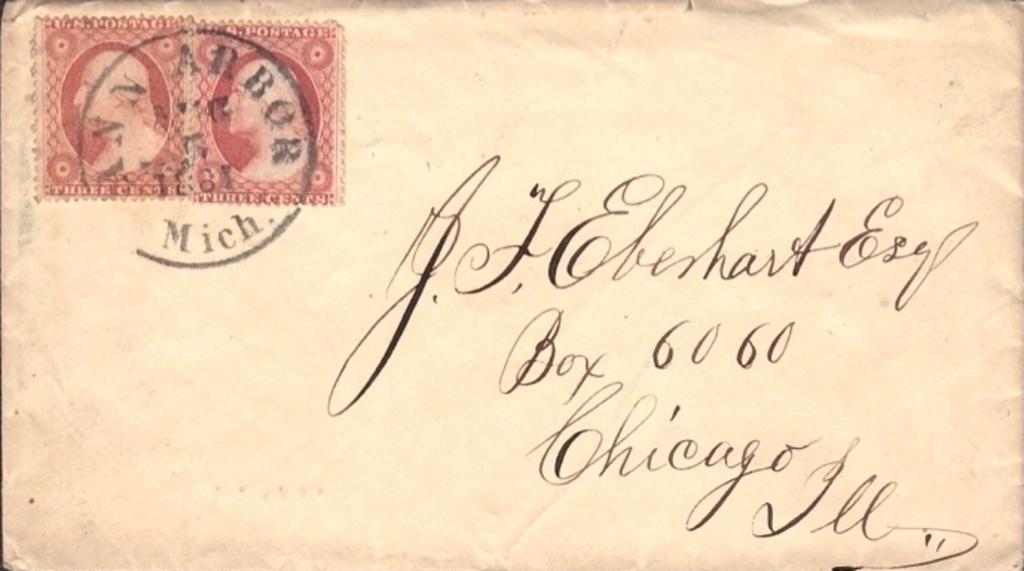What box number?
Your response must be concise. 6060. What state was the letter postmarked in?
Offer a terse response. Michigan. 